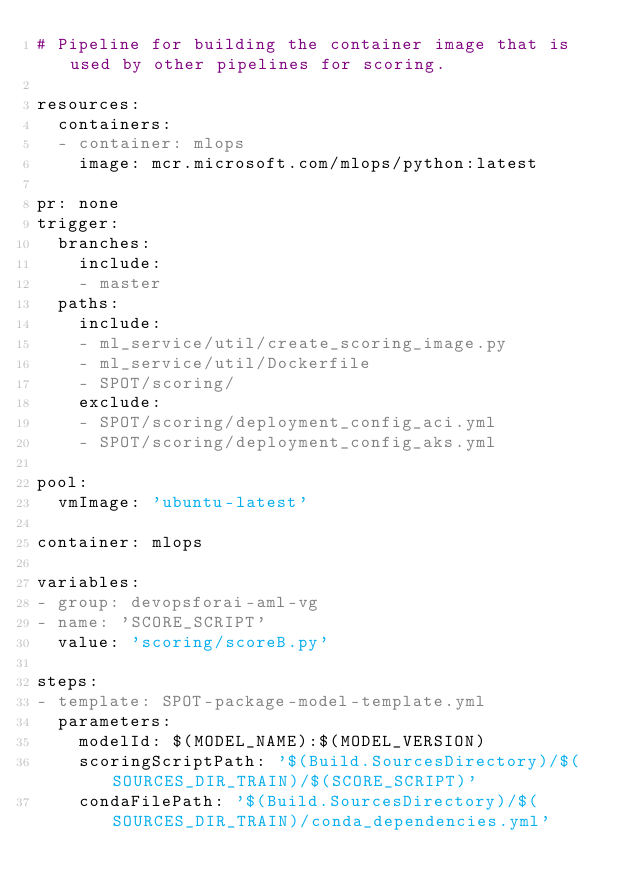<code> <loc_0><loc_0><loc_500><loc_500><_YAML_># Pipeline for building the container image that is used by other pipelines for scoring.

resources:
  containers:
  - container: mlops
    image: mcr.microsoft.com/mlops/python:latest

pr: none
trigger:
  branches:
    include:
    - master
  paths:
    include:
    - ml_service/util/create_scoring_image.py
    - ml_service/util/Dockerfile
    - SPOT/scoring/
    exclude:
    - SPOT/scoring/deployment_config_aci.yml
    - SPOT/scoring/deployment_config_aks.yml

pool: 
  vmImage: 'ubuntu-latest'

container: mlops

variables:
- group: devopsforai-aml-vg
- name: 'SCORE_SCRIPT'
  value: 'scoring/scoreB.py'

steps:
- template: SPOT-package-model-template.yml
  parameters:
    modelId: $(MODEL_NAME):$(MODEL_VERSION)
    scoringScriptPath: '$(Build.SourcesDirectory)/$(SOURCES_DIR_TRAIN)/$(SCORE_SCRIPT)'
    condaFilePath: '$(Build.SourcesDirectory)/$(SOURCES_DIR_TRAIN)/conda_dependencies.yml'

</code> 